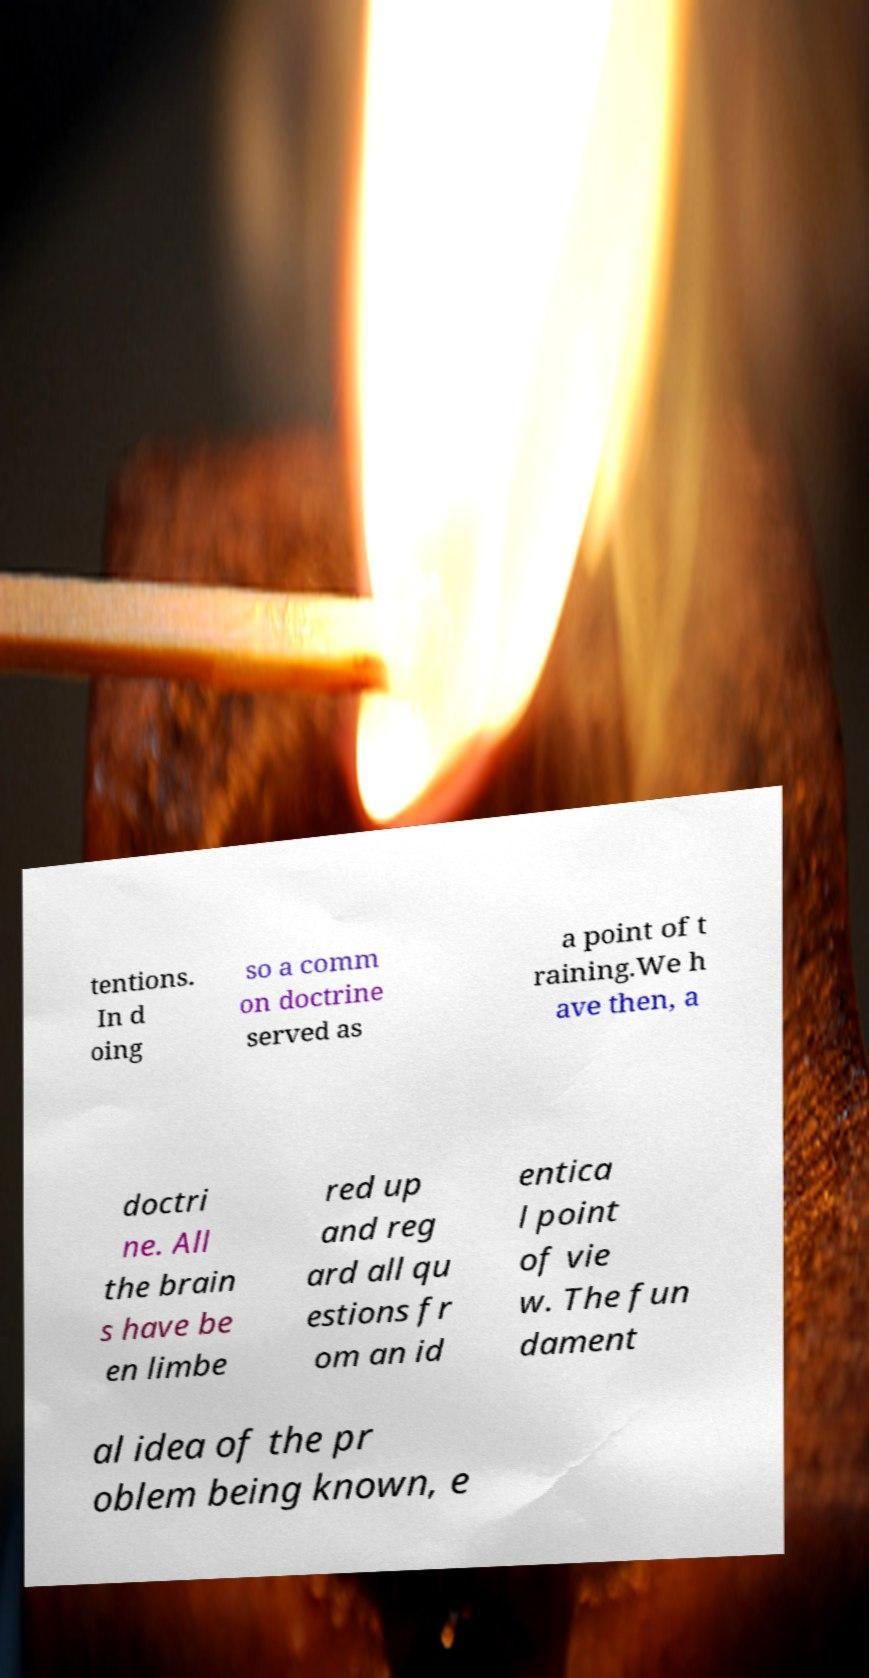For documentation purposes, I need the text within this image transcribed. Could you provide that? tentions. In d oing so a comm on doctrine served as a point of t raining.We h ave then, a doctri ne. All the brain s have be en limbe red up and reg ard all qu estions fr om an id entica l point of vie w. The fun dament al idea of the pr oblem being known, e 